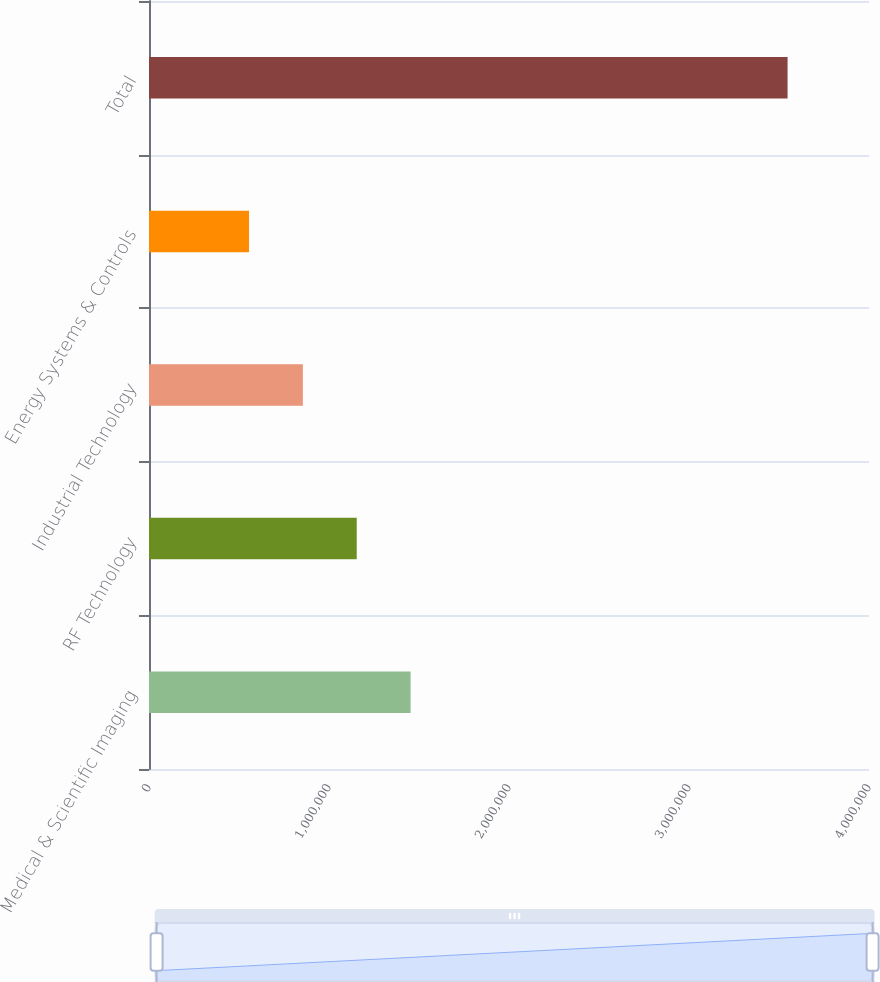Convert chart to OTSL. <chart><loc_0><loc_0><loc_500><loc_500><bar_chart><fcel>Medical & Scientific Imaging<fcel>RF Technology<fcel>Industrial Technology<fcel>Energy Systems & Controls<fcel>Total<nl><fcel>1.45326e+06<fcel>1.15406e+06<fcel>854867<fcel>555672<fcel>3.54762e+06<nl></chart> 